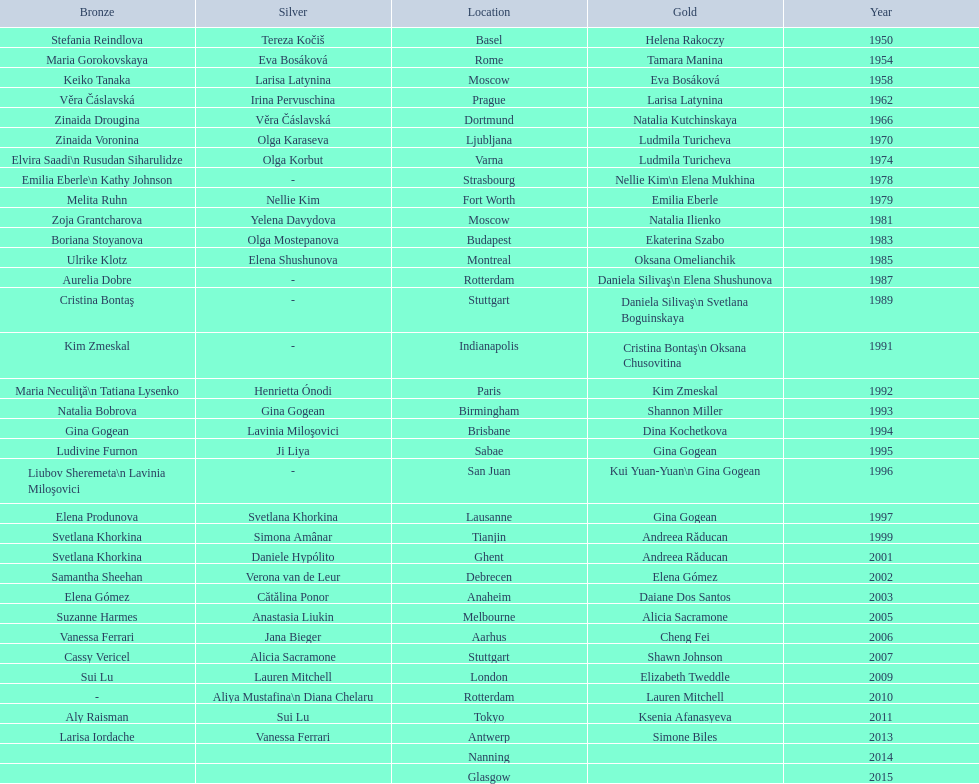How many times was the location in the united states? 3. 